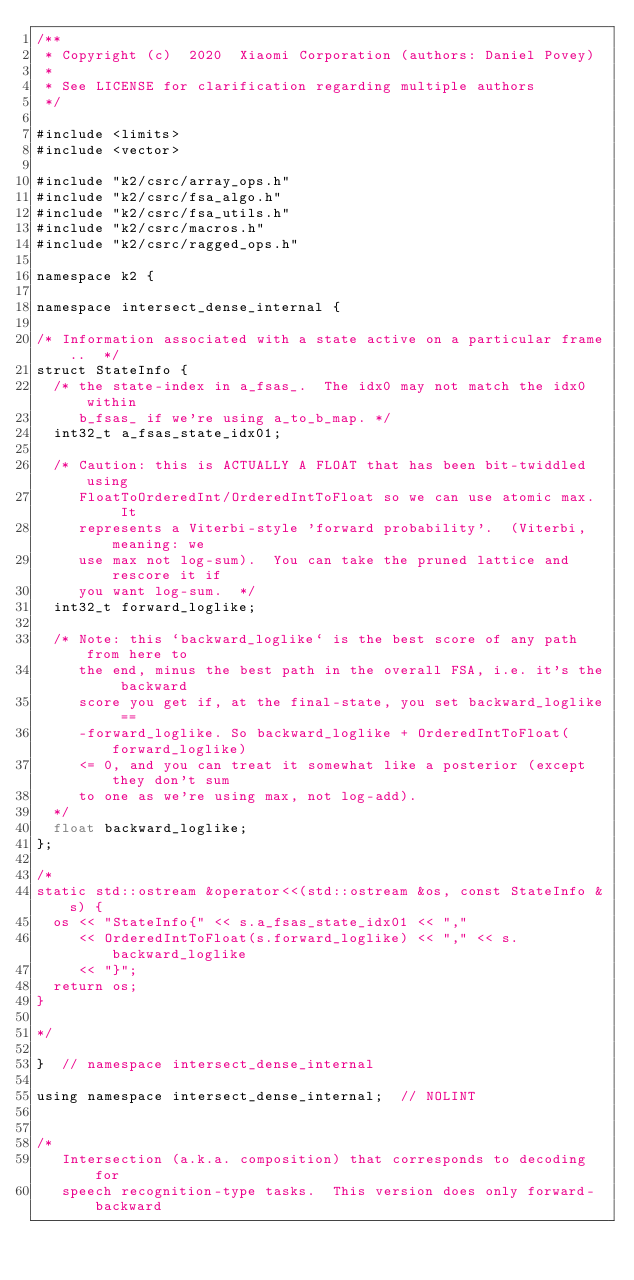Convert code to text. <code><loc_0><loc_0><loc_500><loc_500><_Cuda_>/**
 * Copyright (c)  2020  Xiaomi Corporation (authors: Daniel Povey)
 *
 * See LICENSE for clarification regarding multiple authors
 */

#include <limits>
#include <vector>

#include "k2/csrc/array_ops.h"
#include "k2/csrc/fsa_algo.h"
#include "k2/csrc/fsa_utils.h"
#include "k2/csrc/macros.h"
#include "k2/csrc/ragged_ops.h"

namespace k2 {

namespace intersect_dense_internal {

/* Information associated with a state active on a particular frame..  */
struct StateInfo {
  /* the state-index in a_fsas_.  The idx0 may not match the idx0 within
     b_fsas_ if we're using a_to_b_map. */
  int32_t a_fsas_state_idx01;

  /* Caution: this is ACTUALLY A FLOAT that has been bit-twiddled using
     FloatToOrderedInt/OrderedIntToFloat so we can use atomic max.  It
     represents a Viterbi-style 'forward probability'.  (Viterbi, meaning: we
     use max not log-sum).  You can take the pruned lattice and rescore it if
     you want log-sum.  */
  int32_t forward_loglike;

  /* Note: this `backward_loglike` is the best score of any path from here to
     the end, minus the best path in the overall FSA, i.e. it's the backward
     score you get if, at the final-state, you set backward_loglike ==
     -forward_loglike. So backward_loglike + OrderedIntToFloat(forward_loglike)
     <= 0, and you can treat it somewhat like a posterior (except they don't sum
     to one as we're using max, not log-add).
  */
  float backward_loglike;
};

/*
static std::ostream &operator<<(std::ostream &os, const StateInfo &s) {
  os << "StateInfo{" << s.a_fsas_state_idx01 << ","
     << OrderedIntToFloat(s.forward_loglike) << "," << s.backward_loglike
     << "}";
  return os;
}

*/

}  // namespace intersect_dense_internal

using namespace intersect_dense_internal;  // NOLINT


/*
   Intersection (a.k.a. composition) that corresponds to decoding for
   speech recognition-type tasks.  This version does only forward-backward</code> 